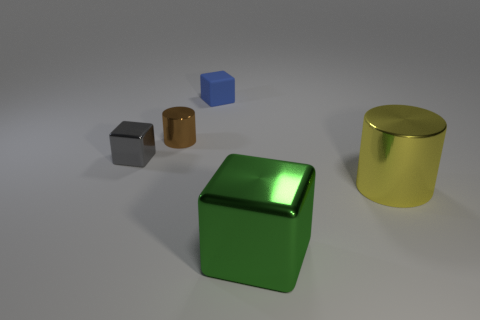Subtract all small blocks. How many blocks are left? 1 Add 4 big rubber spheres. How many objects exist? 9 Subtract all cubes. How many objects are left? 2 Subtract all tiny metal cylinders. Subtract all small brown cylinders. How many objects are left? 3 Add 5 gray metallic cubes. How many gray metallic cubes are left? 6 Add 4 large yellow metal objects. How many large yellow metal objects exist? 5 Subtract 0 yellow cubes. How many objects are left? 5 